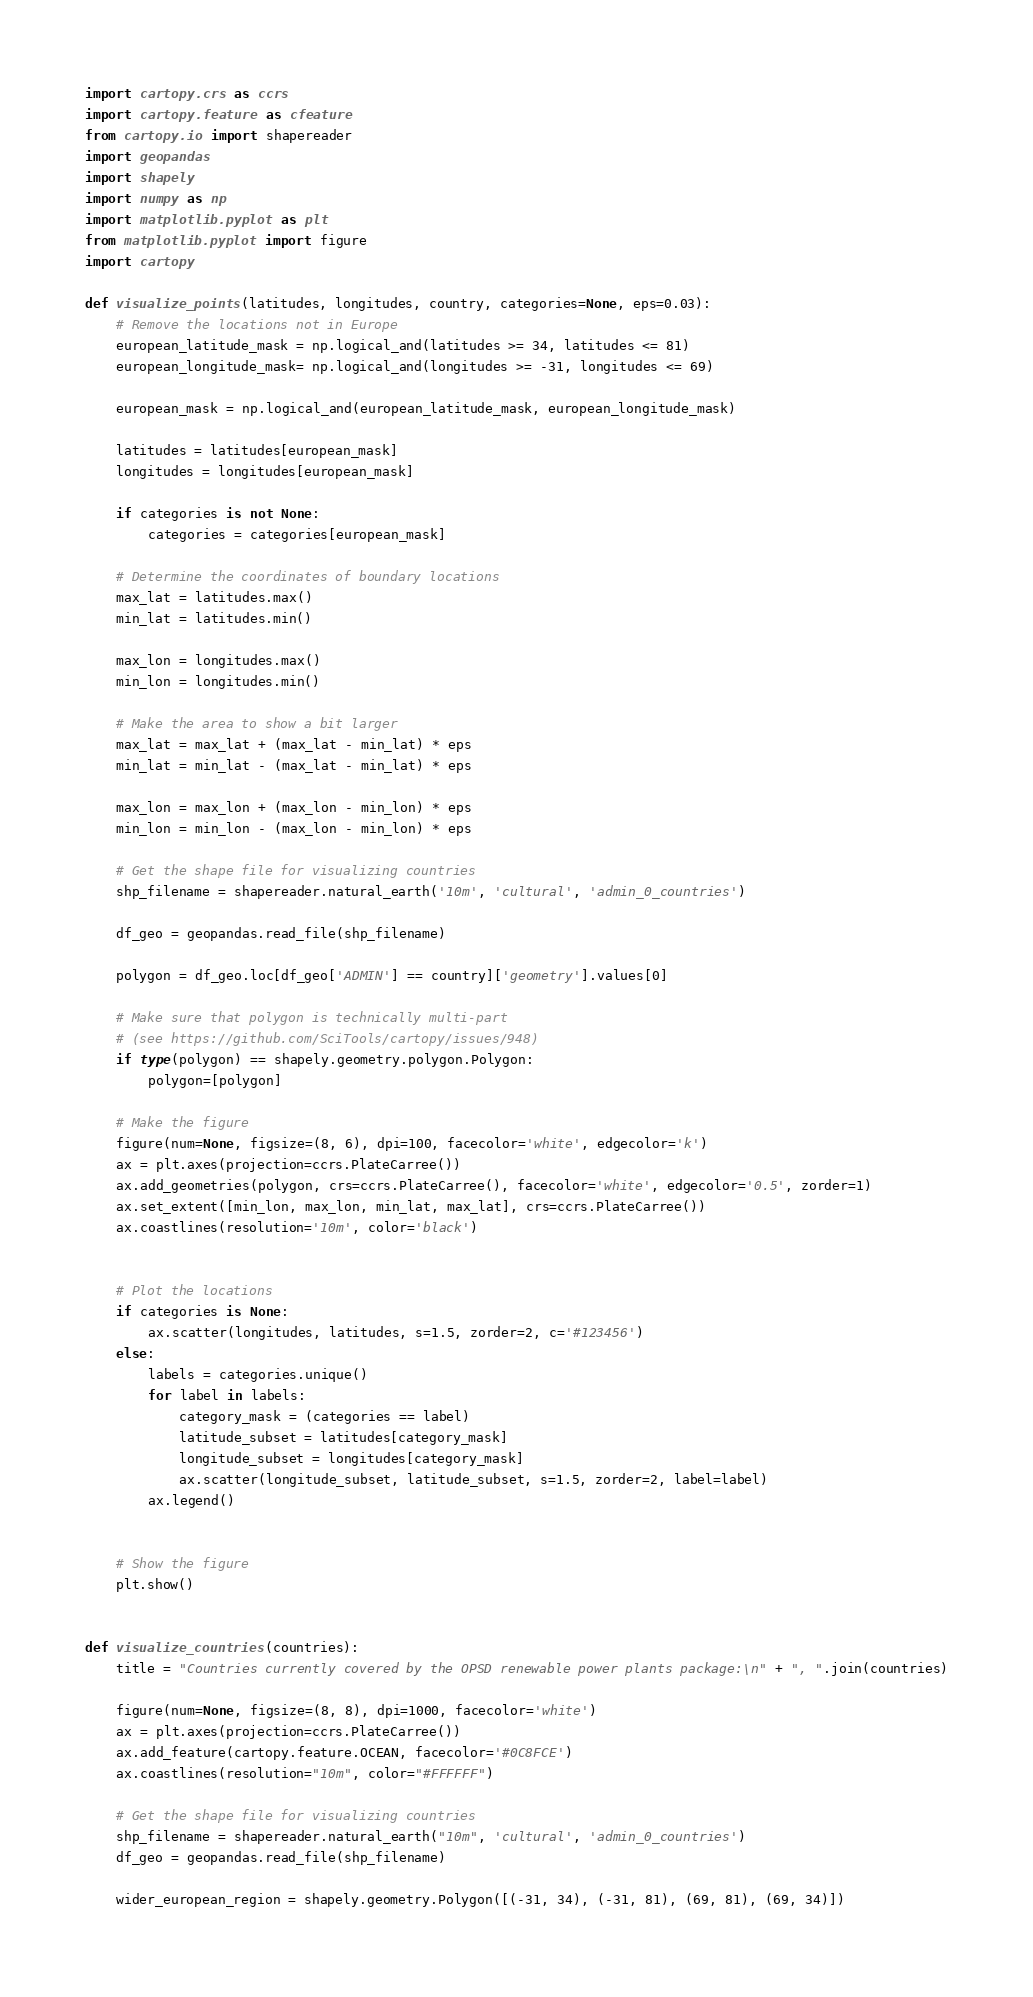<code> <loc_0><loc_0><loc_500><loc_500><_Python_>import cartopy.crs as ccrs 
import cartopy.feature as cfeature
from cartopy.io import shapereader
import geopandas
import shapely
import numpy as np
import matplotlib.pyplot as plt
from matplotlib.pyplot import figure
import cartopy

def visualize_points(latitudes, longitudes, country, categories=None, eps=0.03):
	# Remove the locations not in Europe
	european_latitude_mask = np.logical_and(latitudes >= 34, latitudes <= 81)
	european_longitude_mask= np.logical_and(longitudes >= -31, longitudes <= 69)
	
	european_mask = np.logical_and(european_latitude_mask, european_longitude_mask)
	
	latitudes = latitudes[european_mask]
	longitudes = longitudes[european_mask]

	if categories is not None:
		categories = categories[european_mask]
		
	# Determine the coordinates of boundary locations
	max_lat = latitudes.max()
	min_lat = latitudes.min()

	max_lon = longitudes.max()
	min_lon = longitudes.min()
	
	# Make the area to show a bit larger
	max_lat = max_lat + (max_lat - min_lat) * eps
	min_lat = min_lat - (max_lat - min_lat) * eps
	
	max_lon = max_lon + (max_lon - min_lon) * eps
	min_lon = min_lon - (max_lon - min_lon) * eps
	
	# Get the shape file for visualizing countries
	shp_filename = shapereader.natural_earth('10m', 'cultural', 'admin_0_countries')
	
	df_geo = geopandas.read_file(shp_filename)
	
	polygon = df_geo.loc[df_geo['ADMIN'] == country]['geometry'].values[0]

	# Make sure that polygon is technically multi-part
	# (see https://github.com/SciTools/cartopy/issues/948)
	if type(polygon) == shapely.geometry.polygon.Polygon:
		polygon=[polygon]
		
	# Make the figure
	figure(num=None, figsize=(8, 6), dpi=100, facecolor='white', edgecolor='k')
	ax = plt.axes(projection=ccrs.PlateCarree())
	ax.add_geometries(polygon, crs=ccrs.PlateCarree(), facecolor='white', edgecolor='0.5', zorder=1)
	ax.set_extent([min_lon, max_lon, min_lat, max_lat], crs=ccrs.PlateCarree())
	ax.coastlines(resolution='10m', color='black')

	
	# Plot the locations
	if categories is None:
		ax.scatter(longitudes, latitudes, s=1.5, zorder=2, c='#123456')
	else:
		labels = categories.unique()
		for label in labels:
			category_mask = (categories == label)
			latitude_subset = latitudes[category_mask]
			longitude_subset = longitudes[category_mask]
			ax.scatter(longitude_subset, latitude_subset, s=1.5, zorder=2, label=label)
		ax.legend()
		
	
	# Show the figure
	plt.show()


def visualize_countries(countries):
	title = "Countries currently covered by the OPSD renewable power plants package:\n" + ", ".join(countries)

	figure(num=None, figsize=(8, 8), dpi=1000, facecolor='white')
	ax = plt.axes(projection=ccrs.PlateCarree()) 
	ax.add_feature(cartopy.feature.OCEAN, facecolor='#0C8FCE') 
	ax.coastlines(resolution="10m", color="#FFFFFF")

	# Get the shape file for visualizing countries
	shp_filename = shapereader.natural_earth("10m", 'cultural', 'admin_0_countries')
	df_geo = geopandas.read_file(shp_filename)

	wider_european_region = shapely.geometry.Polygon([(-31, 34), (-31, 81), (69, 81), (69, 34)])</code> 